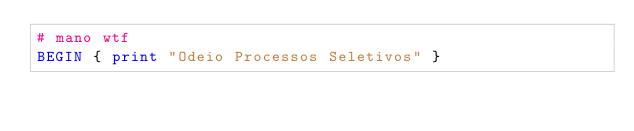Convert code to text. <code><loc_0><loc_0><loc_500><loc_500><_Awk_># mano wtf
BEGIN { print "Odeio Processos Seletivos" }
</code> 